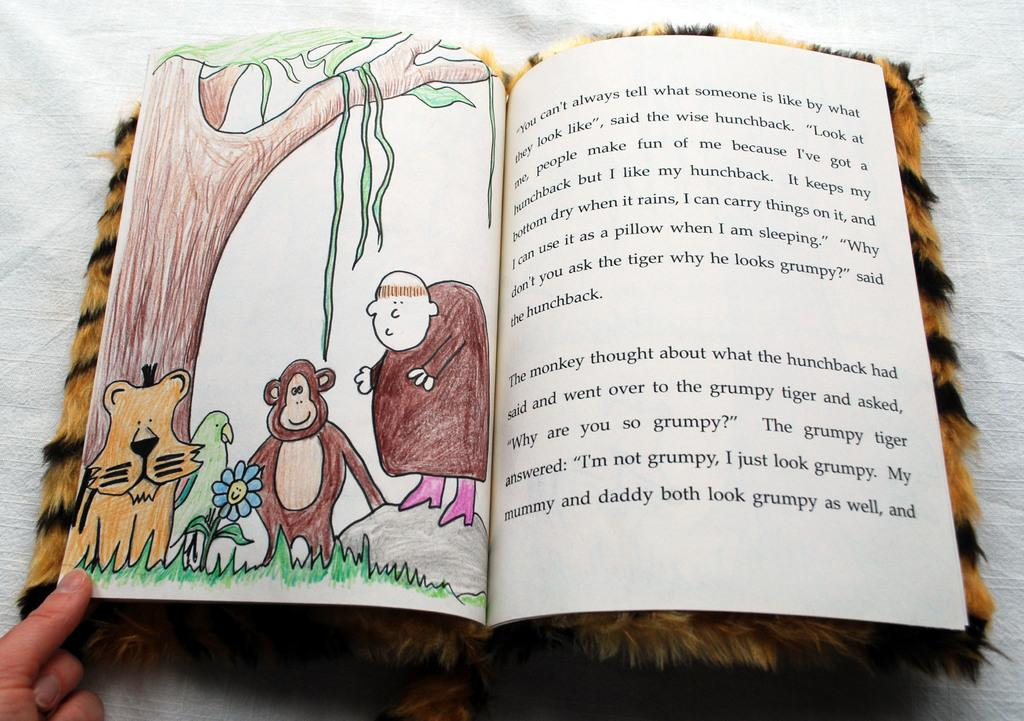<image>
Render a clear and concise summary of the photo. A persons hand holding the bottom left page of an open book with the story about what a monkey thought on the right hand page. 